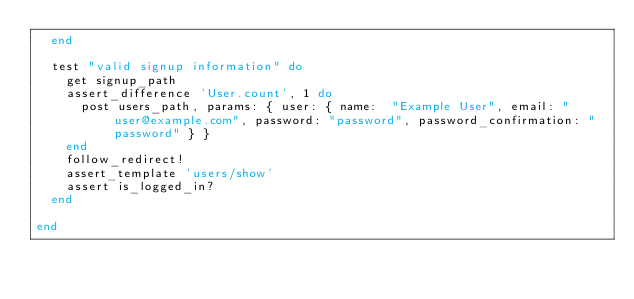Convert code to text. <code><loc_0><loc_0><loc_500><loc_500><_Ruby_>  end
  
  test "valid signup information" do
    get signup_path
    assert_difference 'User.count', 1 do
      post users_path, params: { user: { name:  "Example User", email: "user@example.com", password: "password", password_confirmation: "password" } }
    end
    follow_redirect!
    assert_template 'users/show'
    assert is_logged_in?
  end
  
end
</code> 